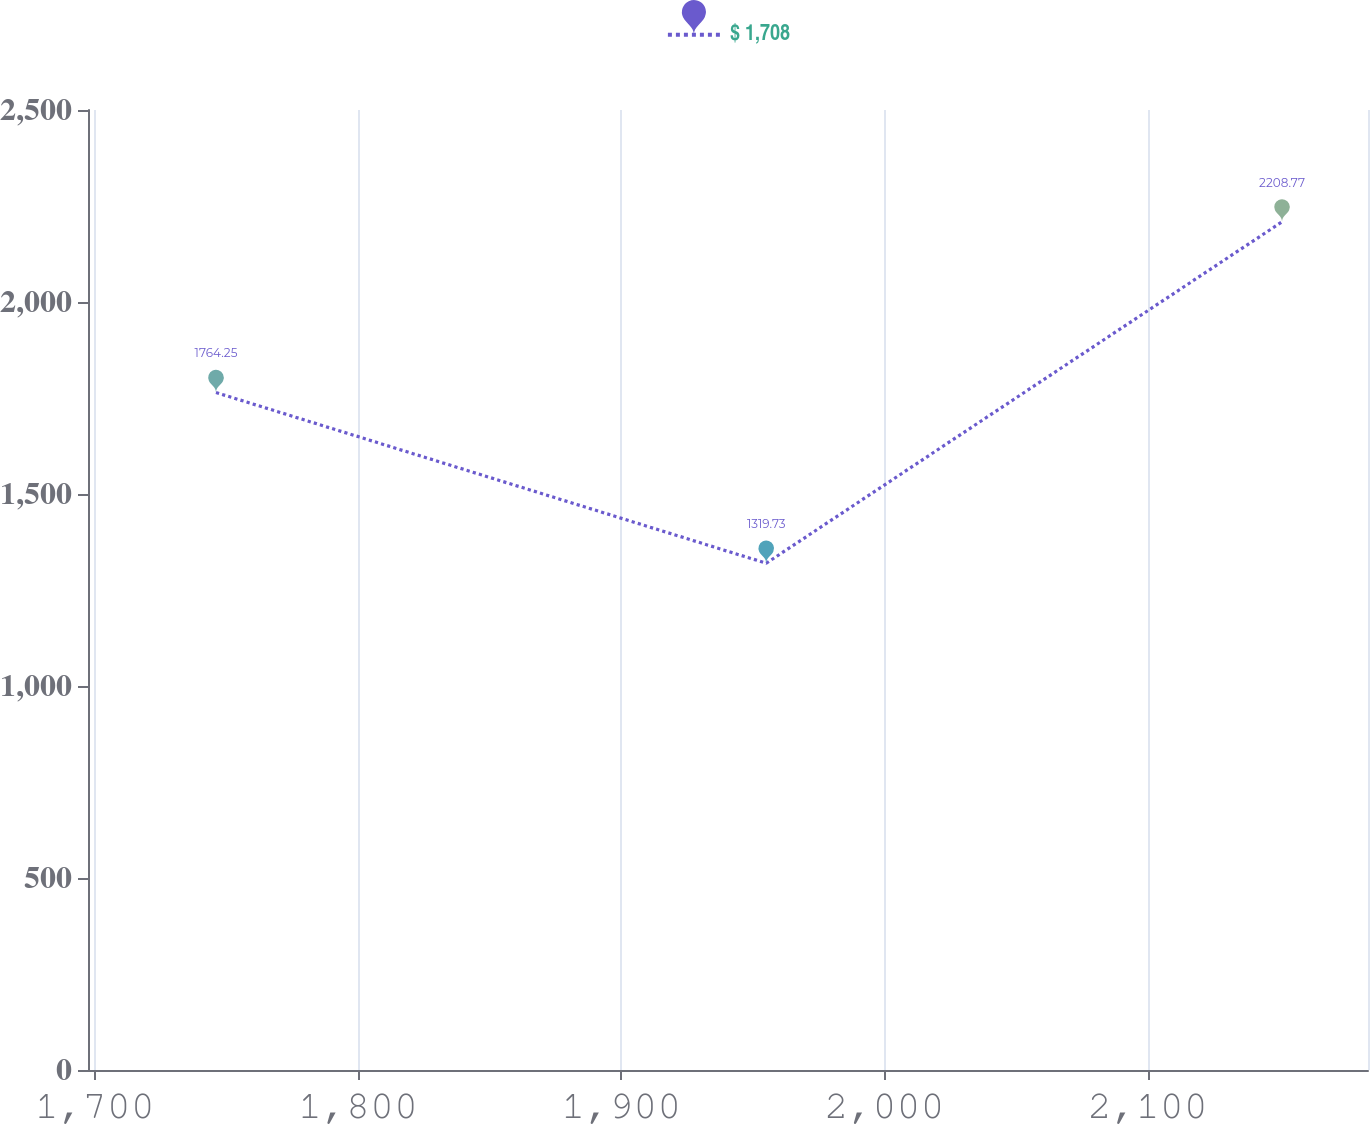Convert chart to OTSL. <chart><loc_0><loc_0><loc_500><loc_500><line_chart><ecel><fcel>$ 1,708<nl><fcel>1746.08<fcel>1764.25<nl><fcel>1955.09<fcel>1319.73<nl><fcel>2151.01<fcel>2208.77<nl><fcel>2232.28<fcel>5764.97<nl></chart> 